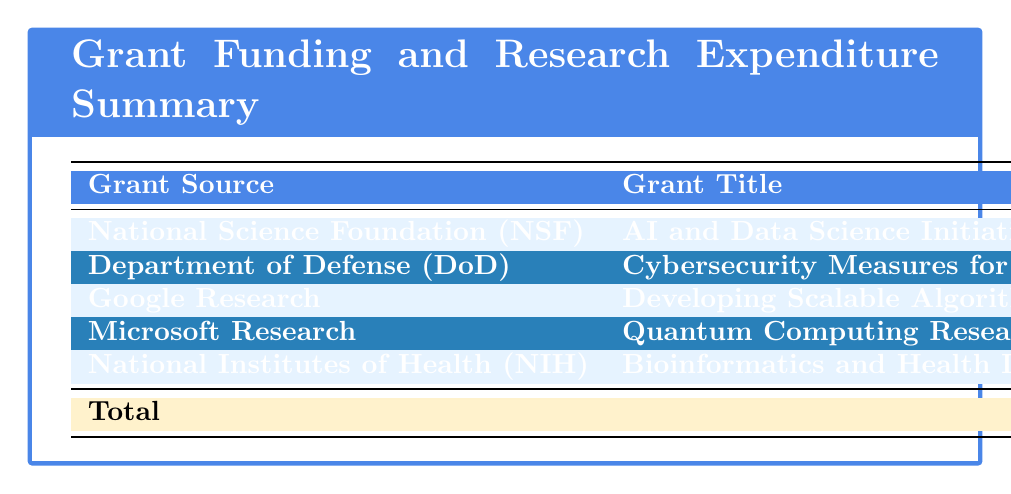What is the total amount awarded across all grants? The table shows the total amount awarded is presented in the summary section, which is clearly specified as 1,475,000 dollars.
Answer: 1,475,000 Which grant source provided the highest research expenditure? By comparing the research expenditure amounts listed, the National Science Foundation (NSF) has the highest expenditure of 480,000 dollars.
Answer: National Science Foundation (NSF) What is the total research expenditure for the Department of Defense (DoD) and Google Research combined? The research expenditure for the DoD is 320,000 dollars and for Google Research is 180,000 dollars. Adding these gives: 320,000 + 180,000 = 500,000 dollars.
Answer: 500,000 Is the amount awarded for the grant titled "Bioinformatics and Health Data Analysis" greater than 100,000 dollars? The amount awarded for this grant is 125,000 dollars, which is indeed greater than 100,000 dollars.
Answer: Yes What is the average research expenditure across all grants? To find the average, sum all research expenditures: 480,000 + 320,000 + 180,000 + 280,000 + 110,000 = 1,370,000 dollars. There are 5 grants, so the average is 1,370,000 / 5 = 274,000 dollars.
Answer: 274,000 Which grant had the lowest amount awarded? By analyzing the amount awarded for each grant, the grant titled "Bioinformatics and Health Data Analysis" from the National Institutes of Health (NIH) has the lowest amount awarded, which is 125,000 dollars.
Answer: Bioinformatics and Health Data Analysis How much more was awarded by the National Science Foundation compared to Microsoft Research? The award from the National Science Foundation is 500,000 dollars and from Microsoft Research is 300,000 dollars. The difference is 500,000 - 300,000 = 200,000 dollars.
Answer: 200,000 Are there any grants with a research expenditure less than 200,000 dollars? After checking each grant’s research expenditure, it's found that both Google Research (180,000 dollars) and National Institutes of Health (110,000 dollars) have expenditures under 200,000 dollars.
Answer: Yes 